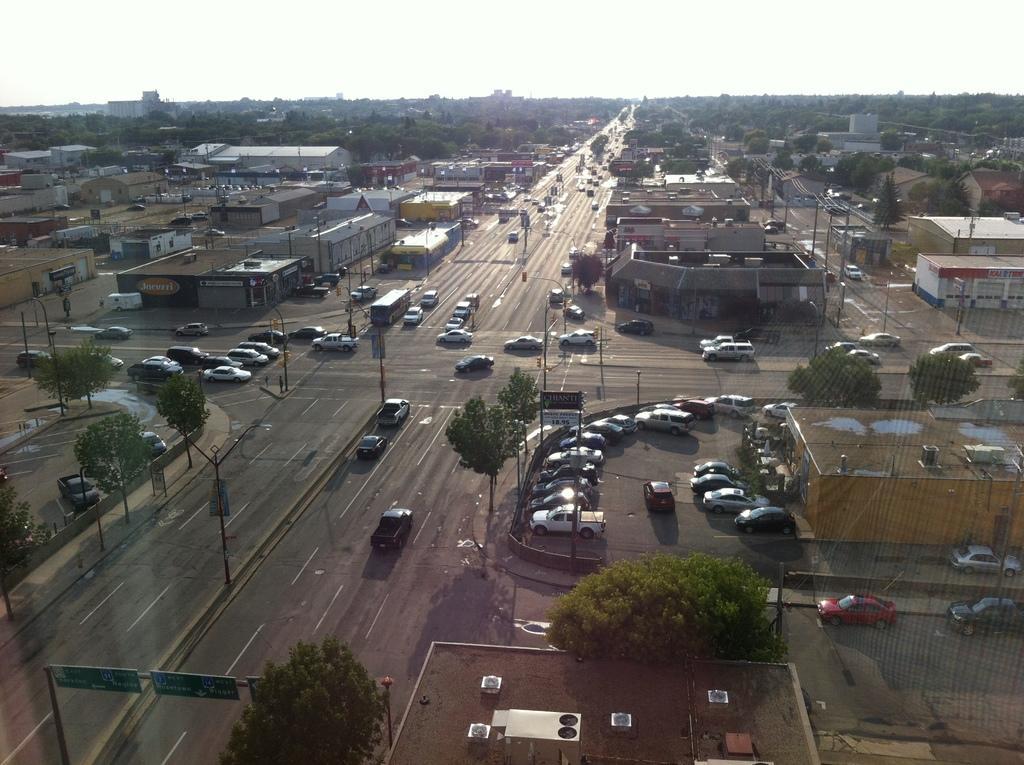Describe this image in one or two sentences. In this picture we can observe roads on which there are cars and other vehicles are moving. There are some trees. We can observe buildings. In the background is a sky. 